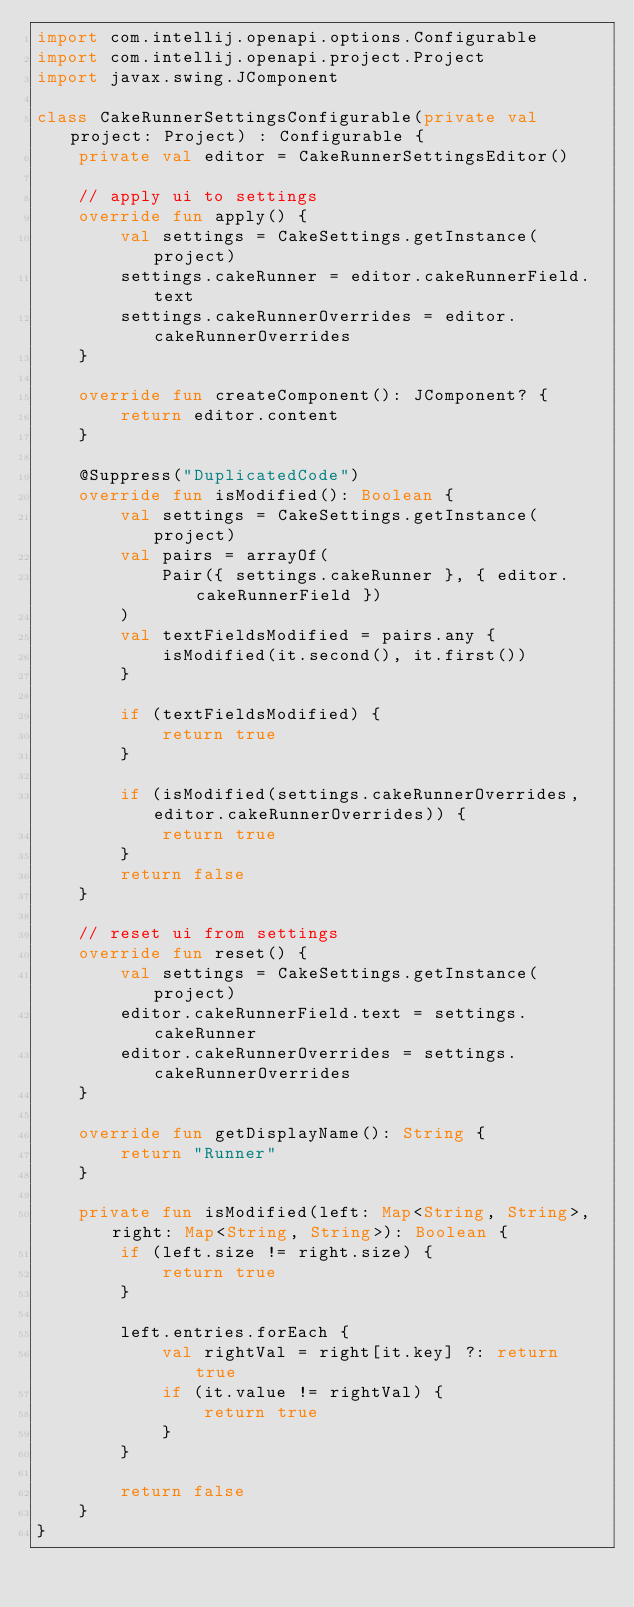Convert code to text. <code><loc_0><loc_0><loc_500><loc_500><_Kotlin_>import com.intellij.openapi.options.Configurable
import com.intellij.openapi.project.Project
import javax.swing.JComponent

class CakeRunnerSettingsConfigurable(private val project: Project) : Configurable {
    private val editor = CakeRunnerSettingsEditor()

    // apply ui to settings
    override fun apply() {
        val settings = CakeSettings.getInstance(project)
        settings.cakeRunner = editor.cakeRunnerField.text
        settings.cakeRunnerOverrides = editor.cakeRunnerOverrides
    }

    override fun createComponent(): JComponent? {
        return editor.content
    }

    @Suppress("DuplicatedCode")
    override fun isModified(): Boolean {
        val settings = CakeSettings.getInstance(project)
        val pairs = arrayOf(
            Pair({ settings.cakeRunner }, { editor.cakeRunnerField })
        )
        val textFieldsModified = pairs.any {
            isModified(it.second(), it.first())
        }

        if (textFieldsModified) {
            return true
        }

        if (isModified(settings.cakeRunnerOverrides, editor.cakeRunnerOverrides)) {
            return true
        }
        return false
    }

    // reset ui from settings
    override fun reset() {
        val settings = CakeSettings.getInstance(project)
        editor.cakeRunnerField.text = settings.cakeRunner
        editor.cakeRunnerOverrides = settings.cakeRunnerOverrides
    }

    override fun getDisplayName(): String {
        return "Runner"
    }

    private fun isModified(left: Map<String, String>, right: Map<String, String>): Boolean {
        if (left.size != right.size) {
            return true
        }

        left.entries.forEach {
            val rightVal = right[it.key] ?: return true
            if (it.value != rightVal) {
                return true
            }
        }

        return false
    }
}
</code> 